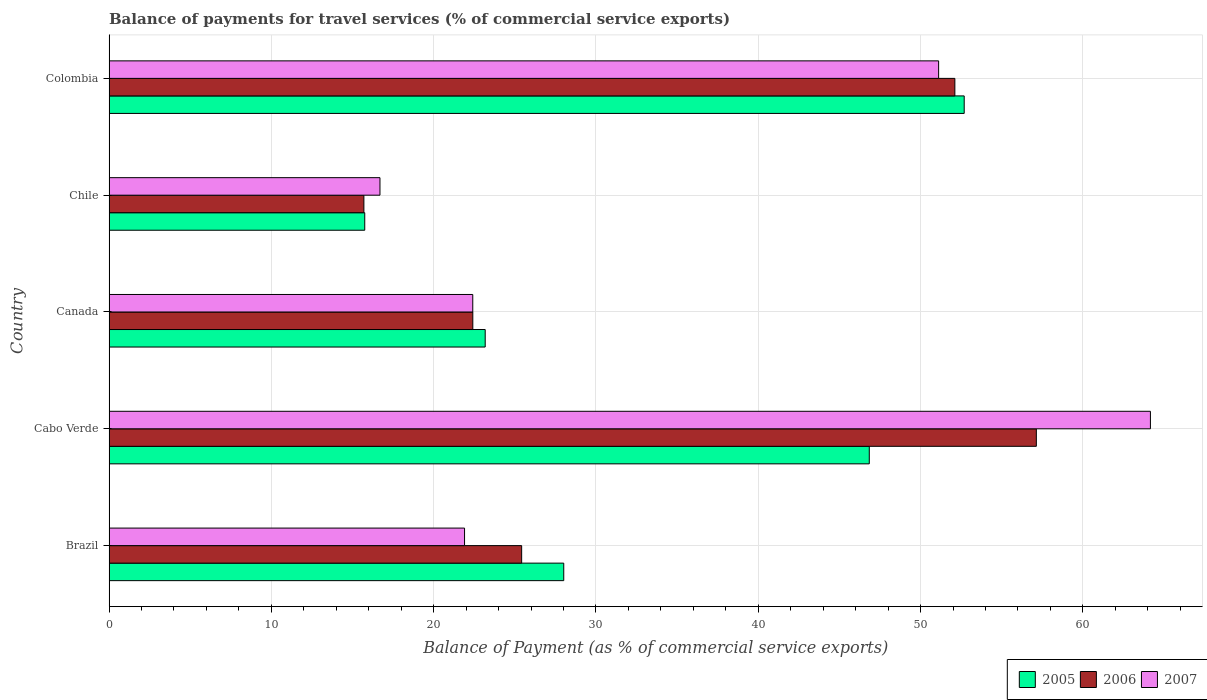Are the number of bars per tick equal to the number of legend labels?
Your response must be concise. Yes. Are the number of bars on each tick of the Y-axis equal?
Your answer should be compact. Yes. How many bars are there on the 4th tick from the top?
Ensure brevity in your answer.  3. In how many cases, is the number of bars for a given country not equal to the number of legend labels?
Give a very brief answer. 0. What is the balance of payments for travel services in 2005 in Colombia?
Offer a very short reply. 52.69. Across all countries, what is the maximum balance of payments for travel services in 2006?
Ensure brevity in your answer.  57.13. Across all countries, what is the minimum balance of payments for travel services in 2005?
Provide a succinct answer. 15.75. In which country was the balance of payments for travel services in 2007 maximum?
Keep it short and to the point. Cabo Verde. What is the total balance of payments for travel services in 2005 in the graph?
Offer a very short reply. 166.47. What is the difference between the balance of payments for travel services in 2006 in Brazil and that in Canada?
Offer a very short reply. 3.01. What is the difference between the balance of payments for travel services in 2006 in Brazil and the balance of payments for travel services in 2007 in Colombia?
Make the answer very short. -25.69. What is the average balance of payments for travel services in 2006 per country?
Keep it short and to the point. 34.55. What is the difference between the balance of payments for travel services in 2005 and balance of payments for travel services in 2007 in Canada?
Give a very brief answer. 0.77. In how many countries, is the balance of payments for travel services in 2006 greater than 42 %?
Your answer should be compact. 2. What is the ratio of the balance of payments for travel services in 2006 in Brazil to that in Cabo Verde?
Your response must be concise. 0.44. Is the balance of payments for travel services in 2007 in Cabo Verde less than that in Chile?
Provide a succinct answer. No. Is the difference between the balance of payments for travel services in 2005 in Cabo Verde and Colombia greater than the difference between the balance of payments for travel services in 2007 in Cabo Verde and Colombia?
Ensure brevity in your answer.  No. What is the difference between the highest and the second highest balance of payments for travel services in 2007?
Keep it short and to the point. 13.05. What is the difference between the highest and the lowest balance of payments for travel services in 2005?
Give a very brief answer. 36.93. What does the 1st bar from the bottom in Brazil represents?
Provide a succinct answer. 2005. How many bars are there?
Your response must be concise. 15. How many countries are there in the graph?
Your response must be concise. 5. What is the difference between two consecutive major ticks on the X-axis?
Keep it short and to the point. 10. Does the graph contain any zero values?
Your response must be concise. No. Does the graph contain grids?
Give a very brief answer. Yes. What is the title of the graph?
Ensure brevity in your answer.  Balance of payments for travel services (% of commercial service exports). What is the label or title of the X-axis?
Make the answer very short. Balance of Payment (as % of commercial service exports). What is the Balance of Payment (as % of commercial service exports) of 2005 in Brazil?
Provide a succinct answer. 28.01. What is the Balance of Payment (as % of commercial service exports) of 2006 in Brazil?
Provide a short and direct response. 25.42. What is the Balance of Payment (as % of commercial service exports) of 2007 in Brazil?
Provide a succinct answer. 21.9. What is the Balance of Payment (as % of commercial service exports) of 2005 in Cabo Verde?
Make the answer very short. 46.84. What is the Balance of Payment (as % of commercial service exports) in 2006 in Cabo Verde?
Your response must be concise. 57.13. What is the Balance of Payment (as % of commercial service exports) of 2007 in Cabo Verde?
Ensure brevity in your answer.  64.16. What is the Balance of Payment (as % of commercial service exports) in 2005 in Canada?
Your answer should be very brief. 23.17. What is the Balance of Payment (as % of commercial service exports) in 2006 in Canada?
Offer a terse response. 22.41. What is the Balance of Payment (as % of commercial service exports) in 2007 in Canada?
Your response must be concise. 22.41. What is the Balance of Payment (as % of commercial service exports) in 2005 in Chile?
Give a very brief answer. 15.75. What is the Balance of Payment (as % of commercial service exports) in 2006 in Chile?
Your answer should be compact. 15.7. What is the Balance of Payment (as % of commercial service exports) of 2007 in Chile?
Ensure brevity in your answer.  16.69. What is the Balance of Payment (as % of commercial service exports) of 2005 in Colombia?
Provide a short and direct response. 52.69. What is the Balance of Payment (as % of commercial service exports) of 2006 in Colombia?
Your answer should be very brief. 52.11. What is the Balance of Payment (as % of commercial service exports) in 2007 in Colombia?
Your response must be concise. 51.11. Across all countries, what is the maximum Balance of Payment (as % of commercial service exports) of 2005?
Your answer should be very brief. 52.69. Across all countries, what is the maximum Balance of Payment (as % of commercial service exports) in 2006?
Keep it short and to the point. 57.13. Across all countries, what is the maximum Balance of Payment (as % of commercial service exports) in 2007?
Your answer should be very brief. 64.16. Across all countries, what is the minimum Balance of Payment (as % of commercial service exports) of 2005?
Offer a terse response. 15.75. Across all countries, what is the minimum Balance of Payment (as % of commercial service exports) of 2006?
Make the answer very short. 15.7. Across all countries, what is the minimum Balance of Payment (as % of commercial service exports) in 2007?
Ensure brevity in your answer.  16.69. What is the total Balance of Payment (as % of commercial service exports) of 2005 in the graph?
Your answer should be compact. 166.47. What is the total Balance of Payment (as % of commercial service exports) in 2006 in the graph?
Provide a succinct answer. 172.77. What is the total Balance of Payment (as % of commercial service exports) of 2007 in the graph?
Offer a terse response. 176.27. What is the difference between the Balance of Payment (as % of commercial service exports) in 2005 in Brazil and that in Cabo Verde?
Offer a very short reply. -18.82. What is the difference between the Balance of Payment (as % of commercial service exports) in 2006 in Brazil and that in Cabo Verde?
Your response must be concise. -31.71. What is the difference between the Balance of Payment (as % of commercial service exports) in 2007 in Brazil and that in Cabo Verde?
Offer a very short reply. -42.26. What is the difference between the Balance of Payment (as % of commercial service exports) in 2005 in Brazil and that in Canada?
Your response must be concise. 4.84. What is the difference between the Balance of Payment (as % of commercial service exports) of 2006 in Brazil and that in Canada?
Give a very brief answer. 3.01. What is the difference between the Balance of Payment (as % of commercial service exports) in 2007 in Brazil and that in Canada?
Give a very brief answer. -0.51. What is the difference between the Balance of Payment (as % of commercial service exports) of 2005 in Brazil and that in Chile?
Your answer should be compact. 12.26. What is the difference between the Balance of Payment (as % of commercial service exports) of 2006 in Brazil and that in Chile?
Provide a succinct answer. 9.72. What is the difference between the Balance of Payment (as % of commercial service exports) in 2007 in Brazil and that in Chile?
Offer a terse response. 5.21. What is the difference between the Balance of Payment (as % of commercial service exports) in 2005 in Brazil and that in Colombia?
Your response must be concise. -24.67. What is the difference between the Balance of Payment (as % of commercial service exports) of 2006 in Brazil and that in Colombia?
Provide a short and direct response. -26.69. What is the difference between the Balance of Payment (as % of commercial service exports) in 2007 in Brazil and that in Colombia?
Your response must be concise. -29.21. What is the difference between the Balance of Payment (as % of commercial service exports) in 2005 in Cabo Verde and that in Canada?
Keep it short and to the point. 23.66. What is the difference between the Balance of Payment (as % of commercial service exports) of 2006 in Cabo Verde and that in Canada?
Offer a terse response. 34.72. What is the difference between the Balance of Payment (as % of commercial service exports) of 2007 in Cabo Verde and that in Canada?
Make the answer very short. 41.75. What is the difference between the Balance of Payment (as % of commercial service exports) of 2005 in Cabo Verde and that in Chile?
Provide a succinct answer. 31.08. What is the difference between the Balance of Payment (as % of commercial service exports) of 2006 in Cabo Verde and that in Chile?
Provide a succinct answer. 41.43. What is the difference between the Balance of Payment (as % of commercial service exports) of 2007 in Cabo Verde and that in Chile?
Ensure brevity in your answer.  47.47. What is the difference between the Balance of Payment (as % of commercial service exports) in 2005 in Cabo Verde and that in Colombia?
Give a very brief answer. -5.85. What is the difference between the Balance of Payment (as % of commercial service exports) in 2006 in Cabo Verde and that in Colombia?
Offer a very short reply. 5.02. What is the difference between the Balance of Payment (as % of commercial service exports) in 2007 in Cabo Verde and that in Colombia?
Your answer should be very brief. 13.05. What is the difference between the Balance of Payment (as % of commercial service exports) of 2005 in Canada and that in Chile?
Provide a short and direct response. 7.42. What is the difference between the Balance of Payment (as % of commercial service exports) in 2006 in Canada and that in Chile?
Offer a terse response. 6.71. What is the difference between the Balance of Payment (as % of commercial service exports) in 2007 in Canada and that in Chile?
Provide a short and direct response. 5.72. What is the difference between the Balance of Payment (as % of commercial service exports) of 2005 in Canada and that in Colombia?
Your answer should be compact. -29.51. What is the difference between the Balance of Payment (as % of commercial service exports) of 2006 in Canada and that in Colombia?
Give a very brief answer. -29.7. What is the difference between the Balance of Payment (as % of commercial service exports) in 2007 in Canada and that in Colombia?
Offer a very short reply. -28.7. What is the difference between the Balance of Payment (as % of commercial service exports) of 2005 in Chile and that in Colombia?
Ensure brevity in your answer.  -36.93. What is the difference between the Balance of Payment (as % of commercial service exports) in 2006 in Chile and that in Colombia?
Provide a short and direct response. -36.41. What is the difference between the Balance of Payment (as % of commercial service exports) in 2007 in Chile and that in Colombia?
Provide a short and direct response. -34.42. What is the difference between the Balance of Payment (as % of commercial service exports) in 2005 in Brazil and the Balance of Payment (as % of commercial service exports) in 2006 in Cabo Verde?
Give a very brief answer. -29.12. What is the difference between the Balance of Payment (as % of commercial service exports) of 2005 in Brazil and the Balance of Payment (as % of commercial service exports) of 2007 in Cabo Verde?
Offer a terse response. -36.15. What is the difference between the Balance of Payment (as % of commercial service exports) of 2006 in Brazil and the Balance of Payment (as % of commercial service exports) of 2007 in Cabo Verde?
Your answer should be compact. -38.74. What is the difference between the Balance of Payment (as % of commercial service exports) of 2005 in Brazil and the Balance of Payment (as % of commercial service exports) of 2006 in Canada?
Your answer should be very brief. 5.6. What is the difference between the Balance of Payment (as % of commercial service exports) of 2005 in Brazil and the Balance of Payment (as % of commercial service exports) of 2007 in Canada?
Your answer should be very brief. 5.61. What is the difference between the Balance of Payment (as % of commercial service exports) of 2006 in Brazil and the Balance of Payment (as % of commercial service exports) of 2007 in Canada?
Your response must be concise. 3.01. What is the difference between the Balance of Payment (as % of commercial service exports) of 2005 in Brazil and the Balance of Payment (as % of commercial service exports) of 2006 in Chile?
Provide a short and direct response. 12.31. What is the difference between the Balance of Payment (as % of commercial service exports) of 2005 in Brazil and the Balance of Payment (as % of commercial service exports) of 2007 in Chile?
Your answer should be very brief. 11.32. What is the difference between the Balance of Payment (as % of commercial service exports) in 2006 in Brazil and the Balance of Payment (as % of commercial service exports) in 2007 in Chile?
Your response must be concise. 8.73. What is the difference between the Balance of Payment (as % of commercial service exports) in 2005 in Brazil and the Balance of Payment (as % of commercial service exports) in 2006 in Colombia?
Give a very brief answer. -24.1. What is the difference between the Balance of Payment (as % of commercial service exports) in 2005 in Brazil and the Balance of Payment (as % of commercial service exports) in 2007 in Colombia?
Provide a short and direct response. -23.1. What is the difference between the Balance of Payment (as % of commercial service exports) of 2006 in Brazil and the Balance of Payment (as % of commercial service exports) of 2007 in Colombia?
Your answer should be compact. -25.69. What is the difference between the Balance of Payment (as % of commercial service exports) of 2005 in Cabo Verde and the Balance of Payment (as % of commercial service exports) of 2006 in Canada?
Give a very brief answer. 24.43. What is the difference between the Balance of Payment (as % of commercial service exports) in 2005 in Cabo Verde and the Balance of Payment (as % of commercial service exports) in 2007 in Canada?
Give a very brief answer. 24.43. What is the difference between the Balance of Payment (as % of commercial service exports) of 2006 in Cabo Verde and the Balance of Payment (as % of commercial service exports) of 2007 in Canada?
Your response must be concise. 34.72. What is the difference between the Balance of Payment (as % of commercial service exports) in 2005 in Cabo Verde and the Balance of Payment (as % of commercial service exports) in 2006 in Chile?
Make the answer very short. 31.14. What is the difference between the Balance of Payment (as % of commercial service exports) in 2005 in Cabo Verde and the Balance of Payment (as % of commercial service exports) in 2007 in Chile?
Make the answer very short. 30.15. What is the difference between the Balance of Payment (as % of commercial service exports) of 2006 in Cabo Verde and the Balance of Payment (as % of commercial service exports) of 2007 in Chile?
Make the answer very short. 40.44. What is the difference between the Balance of Payment (as % of commercial service exports) of 2005 in Cabo Verde and the Balance of Payment (as % of commercial service exports) of 2006 in Colombia?
Ensure brevity in your answer.  -5.27. What is the difference between the Balance of Payment (as % of commercial service exports) in 2005 in Cabo Verde and the Balance of Payment (as % of commercial service exports) in 2007 in Colombia?
Your response must be concise. -4.27. What is the difference between the Balance of Payment (as % of commercial service exports) in 2006 in Cabo Verde and the Balance of Payment (as % of commercial service exports) in 2007 in Colombia?
Give a very brief answer. 6.02. What is the difference between the Balance of Payment (as % of commercial service exports) of 2005 in Canada and the Balance of Payment (as % of commercial service exports) of 2006 in Chile?
Make the answer very short. 7.47. What is the difference between the Balance of Payment (as % of commercial service exports) of 2005 in Canada and the Balance of Payment (as % of commercial service exports) of 2007 in Chile?
Your response must be concise. 6.48. What is the difference between the Balance of Payment (as % of commercial service exports) of 2006 in Canada and the Balance of Payment (as % of commercial service exports) of 2007 in Chile?
Make the answer very short. 5.72. What is the difference between the Balance of Payment (as % of commercial service exports) of 2005 in Canada and the Balance of Payment (as % of commercial service exports) of 2006 in Colombia?
Your answer should be very brief. -28.94. What is the difference between the Balance of Payment (as % of commercial service exports) in 2005 in Canada and the Balance of Payment (as % of commercial service exports) in 2007 in Colombia?
Your answer should be very brief. -27.94. What is the difference between the Balance of Payment (as % of commercial service exports) of 2006 in Canada and the Balance of Payment (as % of commercial service exports) of 2007 in Colombia?
Offer a very short reply. -28.7. What is the difference between the Balance of Payment (as % of commercial service exports) of 2005 in Chile and the Balance of Payment (as % of commercial service exports) of 2006 in Colombia?
Provide a short and direct response. -36.36. What is the difference between the Balance of Payment (as % of commercial service exports) of 2005 in Chile and the Balance of Payment (as % of commercial service exports) of 2007 in Colombia?
Keep it short and to the point. -35.36. What is the difference between the Balance of Payment (as % of commercial service exports) of 2006 in Chile and the Balance of Payment (as % of commercial service exports) of 2007 in Colombia?
Provide a short and direct response. -35.41. What is the average Balance of Payment (as % of commercial service exports) in 2005 per country?
Offer a terse response. 33.29. What is the average Balance of Payment (as % of commercial service exports) of 2006 per country?
Your response must be concise. 34.55. What is the average Balance of Payment (as % of commercial service exports) in 2007 per country?
Offer a terse response. 35.25. What is the difference between the Balance of Payment (as % of commercial service exports) of 2005 and Balance of Payment (as % of commercial service exports) of 2006 in Brazil?
Provide a short and direct response. 2.59. What is the difference between the Balance of Payment (as % of commercial service exports) in 2005 and Balance of Payment (as % of commercial service exports) in 2007 in Brazil?
Your response must be concise. 6.11. What is the difference between the Balance of Payment (as % of commercial service exports) of 2006 and Balance of Payment (as % of commercial service exports) of 2007 in Brazil?
Your answer should be compact. 3.52. What is the difference between the Balance of Payment (as % of commercial service exports) of 2005 and Balance of Payment (as % of commercial service exports) of 2006 in Cabo Verde?
Keep it short and to the point. -10.29. What is the difference between the Balance of Payment (as % of commercial service exports) of 2005 and Balance of Payment (as % of commercial service exports) of 2007 in Cabo Verde?
Provide a short and direct response. -17.32. What is the difference between the Balance of Payment (as % of commercial service exports) in 2006 and Balance of Payment (as % of commercial service exports) in 2007 in Cabo Verde?
Provide a succinct answer. -7.03. What is the difference between the Balance of Payment (as % of commercial service exports) of 2005 and Balance of Payment (as % of commercial service exports) of 2006 in Canada?
Ensure brevity in your answer.  0.76. What is the difference between the Balance of Payment (as % of commercial service exports) of 2005 and Balance of Payment (as % of commercial service exports) of 2007 in Canada?
Offer a very short reply. 0.77. What is the difference between the Balance of Payment (as % of commercial service exports) in 2006 and Balance of Payment (as % of commercial service exports) in 2007 in Canada?
Offer a very short reply. 0. What is the difference between the Balance of Payment (as % of commercial service exports) in 2005 and Balance of Payment (as % of commercial service exports) in 2006 in Chile?
Your answer should be compact. 0.05. What is the difference between the Balance of Payment (as % of commercial service exports) of 2005 and Balance of Payment (as % of commercial service exports) of 2007 in Chile?
Offer a terse response. -0.94. What is the difference between the Balance of Payment (as % of commercial service exports) in 2006 and Balance of Payment (as % of commercial service exports) in 2007 in Chile?
Provide a short and direct response. -0.99. What is the difference between the Balance of Payment (as % of commercial service exports) in 2005 and Balance of Payment (as % of commercial service exports) in 2006 in Colombia?
Keep it short and to the point. 0.58. What is the difference between the Balance of Payment (as % of commercial service exports) of 2005 and Balance of Payment (as % of commercial service exports) of 2007 in Colombia?
Make the answer very short. 1.58. What is the ratio of the Balance of Payment (as % of commercial service exports) of 2005 in Brazil to that in Cabo Verde?
Ensure brevity in your answer.  0.6. What is the ratio of the Balance of Payment (as % of commercial service exports) in 2006 in Brazil to that in Cabo Verde?
Offer a terse response. 0.44. What is the ratio of the Balance of Payment (as % of commercial service exports) of 2007 in Brazil to that in Cabo Verde?
Provide a short and direct response. 0.34. What is the ratio of the Balance of Payment (as % of commercial service exports) in 2005 in Brazil to that in Canada?
Give a very brief answer. 1.21. What is the ratio of the Balance of Payment (as % of commercial service exports) in 2006 in Brazil to that in Canada?
Offer a very short reply. 1.13. What is the ratio of the Balance of Payment (as % of commercial service exports) of 2007 in Brazil to that in Canada?
Offer a very short reply. 0.98. What is the ratio of the Balance of Payment (as % of commercial service exports) of 2005 in Brazil to that in Chile?
Make the answer very short. 1.78. What is the ratio of the Balance of Payment (as % of commercial service exports) in 2006 in Brazil to that in Chile?
Your answer should be compact. 1.62. What is the ratio of the Balance of Payment (as % of commercial service exports) of 2007 in Brazil to that in Chile?
Your answer should be compact. 1.31. What is the ratio of the Balance of Payment (as % of commercial service exports) of 2005 in Brazil to that in Colombia?
Your answer should be very brief. 0.53. What is the ratio of the Balance of Payment (as % of commercial service exports) of 2006 in Brazil to that in Colombia?
Give a very brief answer. 0.49. What is the ratio of the Balance of Payment (as % of commercial service exports) of 2007 in Brazil to that in Colombia?
Ensure brevity in your answer.  0.43. What is the ratio of the Balance of Payment (as % of commercial service exports) of 2005 in Cabo Verde to that in Canada?
Ensure brevity in your answer.  2.02. What is the ratio of the Balance of Payment (as % of commercial service exports) in 2006 in Cabo Verde to that in Canada?
Keep it short and to the point. 2.55. What is the ratio of the Balance of Payment (as % of commercial service exports) of 2007 in Cabo Verde to that in Canada?
Your answer should be compact. 2.86. What is the ratio of the Balance of Payment (as % of commercial service exports) in 2005 in Cabo Verde to that in Chile?
Your answer should be very brief. 2.97. What is the ratio of the Balance of Payment (as % of commercial service exports) of 2006 in Cabo Verde to that in Chile?
Your response must be concise. 3.64. What is the ratio of the Balance of Payment (as % of commercial service exports) of 2007 in Cabo Verde to that in Chile?
Offer a terse response. 3.84. What is the ratio of the Balance of Payment (as % of commercial service exports) of 2005 in Cabo Verde to that in Colombia?
Your answer should be very brief. 0.89. What is the ratio of the Balance of Payment (as % of commercial service exports) of 2006 in Cabo Verde to that in Colombia?
Ensure brevity in your answer.  1.1. What is the ratio of the Balance of Payment (as % of commercial service exports) of 2007 in Cabo Verde to that in Colombia?
Your response must be concise. 1.26. What is the ratio of the Balance of Payment (as % of commercial service exports) of 2005 in Canada to that in Chile?
Give a very brief answer. 1.47. What is the ratio of the Balance of Payment (as % of commercial service exports) in 2006 in Canada to that in Chile?
Offer a terse response. 1.43. What is the ratio of the Balance of Payment (as % of commercial service exports) of 2007 in Canada to that in Chile?
Your response must be concise. 1.34. What is the ratio of the Balance of Payment (as % of commercial service exports) in 2005 in Canada to that in Colombia?
Provide a succinct answer. 0.44. What is the ratio of the Balance of Payment (as % of commercial service exports) of 2006 in Canada to that in Colombia?
Make the answer very short. 0.43. What is the ratio of the Balance of Payment (as % of commercial service exports) of 2007 in Canada to that in Colombia?
Offer a very short reply. 0.44. What is the ratio of the Balance of Payment (as % of commercial service exports) in 2005 in Chile to that in Colombia?
Your answer should be compact. 0.3. What is the ratio of the Balance of Payment (as % of commercial service exports) in 2006 in Chile to that in Colombia?
Make the answer very short. 0.3. What is the ratio of the Balance of Payment (as % of commercial service exports) of 2007 in Chile to that in Colombia?
Your answer should be compact. 0.33. What is the difference between the highest and the second highest Balance of Payment (as % of commercial service exports) in 2005?
Offer a terse response. 5.85. What is the difference between the highest and the second highest Balance of Payment (as % of commercial service exports) in 2006?
Offer a terse response. 5.02. What is the difference between the highest and the second highest Balance of Payment (as % of commercial service exports) in 2007?
Your answer should be very brief. 13.05. What is the difference between the highest and the lowest Balance of Payment (as % of commercial service exports) in 2005?
Provide a succinct answer. 36.93. What is the difference between the highest and the lowest Balance of Payment (as % of commercial service exports) of 2006?
Offer a terse response. 41.43. What is the difference between the highest and the lowest Balance of Payment (as % of commercial service exports) in 2007?
Keep it short and to the point. 47.47. 